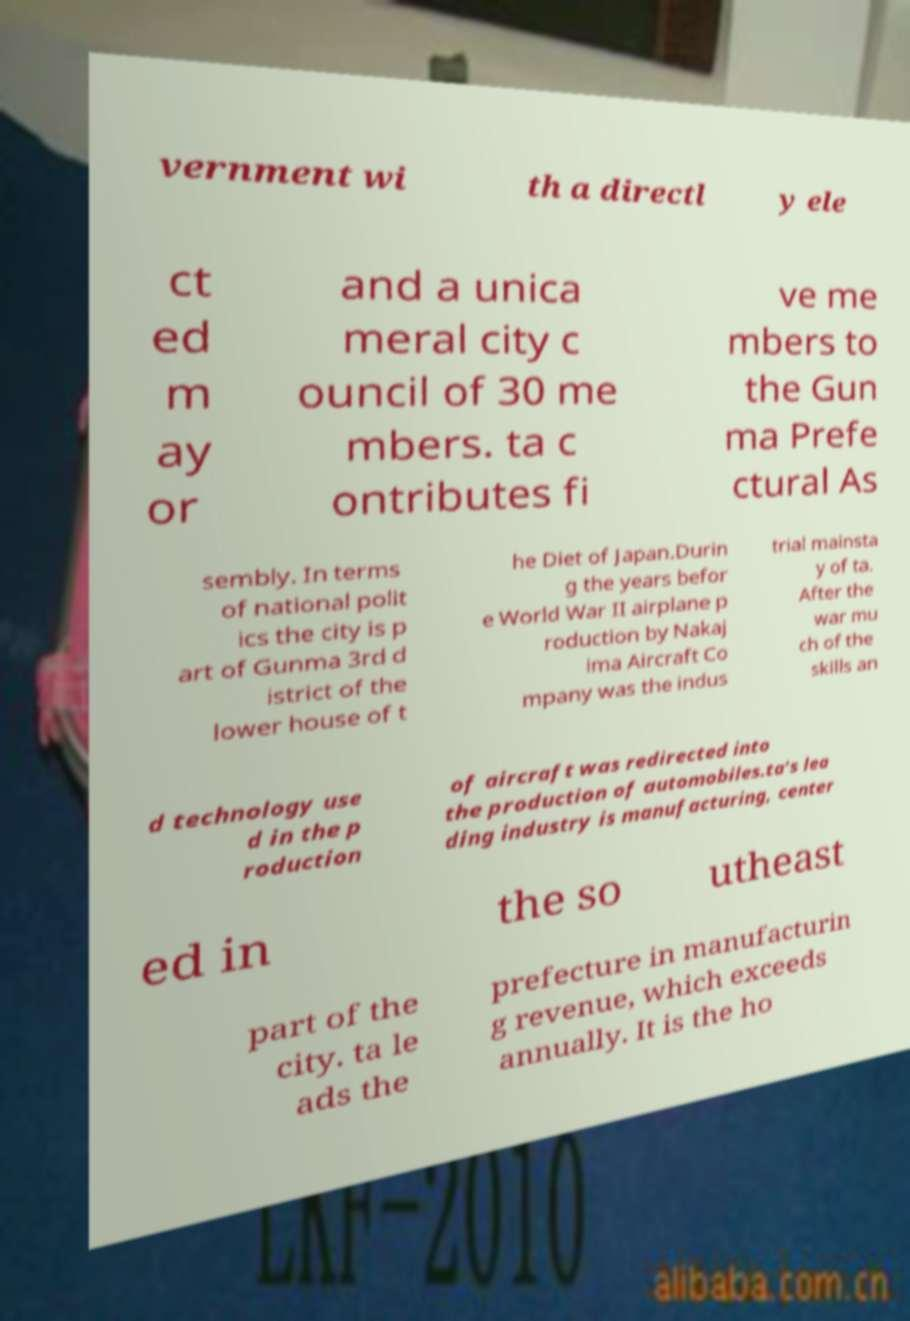Can you read and provide the text displayed in the image?This photo seems to have some interesting text. Can you extract and type it out for me? vernment wi th a directl y ele ct ed m ay or and a unica meral city c ouncil of 30 me mbers. ta c ontributes fi ve me mbers to the Gun ma Prefe ctural As sembly. In terms of national polit ics the city is p art of Gunma 3rd d istrict of the lower house of t he Diet of Japan.Durin g the years befor e World War II airplane p roduction by Nakaj ima Aircraft Co mpany was the indus trial mainsta y of ta. After the war mu ch of the skills an d technology use d in the p roduction of aircraft was redirected into the production of automobiles.ta's lea ding industry is manufacturing, center ed in the so utheast part of the city. ta le ads the prefecture in manufacturin g revenue, which exceeds annually. It is the ho 